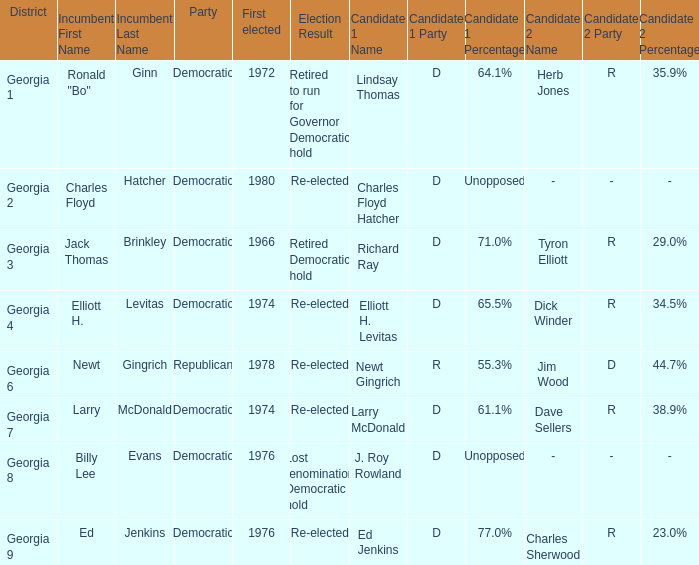Name the party for jack thomas brinkley Democratic. Could you parse the entire table as a dict? {'header': ['District', 'Incumbent First Name', 'Incumbent Last Name', 'Party', 'First elected', 'Election Result', 'Candidate 1 Name', 'Candidate 1 Party', 'Candidate 1 Percentage', 'Candidate 2 Name', 'Candidate 2 Party', 'Candidate 2 Percentage'], 'rows': [['Georgia 1', 'Ronald "Bo"', 'Ginn', 'Democratic', '1972', 'Retired to run for Governor Democratic hold', 'Lindsay Thomas', 'D', '64.1%', 'Herb Jones', 'R', '35.9%'], ['Georgia 2', 'Charles Floyd', 'Hatcher', 'Democratic', '1980', 'Re-elected', 'Charles Floyd Hatcher', 'D', 'Unopposed', '-', '-', '-'], ['Georgia 3', 'Jack Thomas', 'Brinkley', 'Democratic', '1966', 'Retired Democratic hold', 'Richard Ray', 'D', '71.0%', 'Tyron Elliott', 'R', '29.0%'], ['Georgia 4', 'Elliott H.', 'Levitas', 'Democratic', '1974', 'Re-elected', 'Elliott H. Levitas', 'D', '65.5%', 'Dick Winder', 'R', '34.5%'], ['Georgia 6', 'Newt', 'Gingrich', 'Republican', '1978', 'Re-elected', 'Newt Gingrich', 'R', '55.3%', 'Jim Wood', 'D', '44.7%'], ['Georgia 7', 'Larry', 'McDonald', 'Democratic', '1974', 'Re-elected', 'Larry McDonald', 'D', '61.1%', 'Dave Sellers', 'R', '38.9%'], ['Georgia 8', 'Billy Lee', 'Evans', 'Democratic', '1976', 'Lost renomination Democratic hold', 'J. Roy Rowland', 'D', 'Unopposed', '-', '-', '-'], ['Georgia 9', 'Ed', 'Jenkins', 'Democratic', '1976', 'Re-elected', 'Ed Jenkins', 'D', '77.0%', 'Charles Sherwood', 'R', '23.0%']]} 